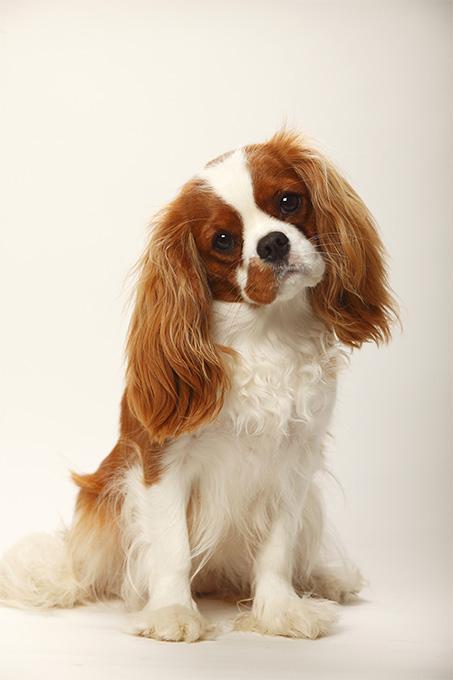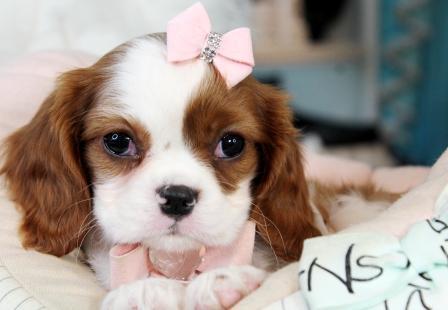The first image is the image on the left, the second image is the image on the right. Assess this claim about the two images: "There are at least two puppies in the right image.". Correct or not? Answer yes or no. No. The first image is the image on the left, the second image is the image on the right. Examine the images to the left and right. Is the description "Left image contains a puppy wearing a pink heart charm on its collar." accurate? Answer yes or no. No. 